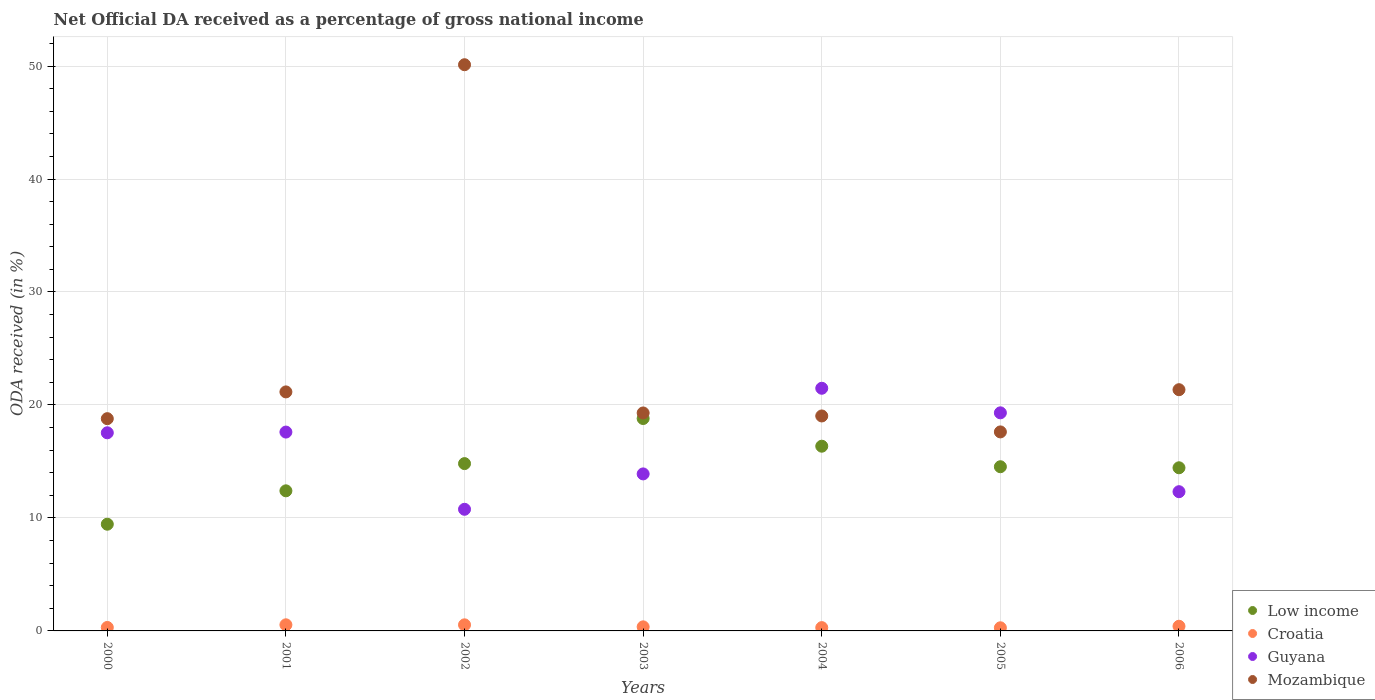How many different coloured dotlines are there?
Give a very brief answer. 4. What is the net official DA received in Mozambique in 2006?
Offer a terse response. 21.35. Across all years, what is the maximum net official DA received in Croatia?
Your answer should be very brief. 0.54. Across all years, what is the minimum net official DA received in Low income?
Your response must be concise. 9.45. In which year was the net official DA received in Mozambique maximum?
Offer a terse response. 2002. In which year was the net official DA received in Croatia minimum?
Your answer should be compact. 2005. What is the total net official DA received in Mozambique in the graph?
Offer a terse response. 167.34. What is the difference between the net official DA received in Low income in 2005 and that in 2006?
Your response must be concise. 0.09. What is the difference between the net official DA received in Mozambique in 2006 and the net official DA received in Croatia in 2004?
Provide a short and direct response. 21.06. What is the average net official DA received in Guyana per year?
Give a very brief answer. 16.13. In the year 2000, what is the difference between the net official DA received in Low income and net official DA received in Guyana?
Keep it short and to the point. -8.09. In how many years, is the net official DA received in Mozambique greater than 16 %?
Ensure brevity in your answer.  7. What is the ratio of the net official DA received in Low income in 2002 to that in 2005?
Your answer should be compact. 1.02. Is the difference between the net official DA received in Low income in 2000 and 2001 greater than the difference between the net official DA received in Guyana in 2000 and 2001?
Make the answer very short. No. What is the difference between the highest and the second highest net official DA received in Guyana?
Ensure brevity in your answer.  2.17. What is the difference between the highest and the lowest net official DA received in Mozambique?
Provide a short and direct response. 32.5. Is the sum of the net official DA received in Low income in 2004 and 2006 greater than the maximum net official DA received in Croatia across all years?
Give a very brief answer. Yes. Is it the case that in every year, the sum of the net official DA received in Mozambique and net official DA received in Low income  is greater than the sum of net official DA received in Guyana and net official DA received in Croatia?
Your answer should be very brief. No. Is it the case that in every year, the sum of the net official DA received in Mozambique and net official DA received in Guyana  is greater than the net official DA received in Croatia?
Your response must be concise. Yes. How many dotlines are there?
Your answer should be compact. 4. Are the values on the major ticks of Y-axis written in scientific E-notation?
Your answer should be compact. No. Does the graph contain grids?
Your answer should be compact. Yes. How are the legend labels stacked?
Ensure brevity in your answer.  Vertical. What is the title of the graph?
Keep it short and to the point. Net Official DA received as a percentage of gross national income. Does "Tuvalu" appear as one of the legend labels in the graph?
Your answer should be compact. No. What is the label or title of the Y-axis?
Ensure brevity in your answer.  ODA received (in %). What is the ODA received (in %) in Low income in 2000?
Your answer should be compact. 9.45. What is the ODA received (in %) of Croatia in 2000?
Offer a very short reply. 0.31. What is the ODA received (in %) in Guyana in 2000?
Your answer should be very brief. 17.54. What is the ODA received (in %) in Mozambique in 2000?
Make the answer very short. 18.79. What is the ODA received (in %) of Low income in 2001?
Your response must be concise. 12.4. What is the ODA received (in %) in Croatia in 2001?
Provide a succinct answer. 0.54. What is the ODA received (in %) of Guyana in 2001?
Keep it short and to the point. 17.6. What is the ODA received (in %) in Mozambique in 2001?
Provide a short and direct response. 21.16. What is the ODA received (in %) in Low income in 2002?
Your response must be concise. 14.81. What is the ODA received (in %) in Croatia in 2002?
Offer a terse response. 0.54. What is the ODA received (in %) in Guyana in 2002?
Ensure brevity in your answer.  10.77. What is the ODA received (in %) in Mozambique in 2002?
Provide a short and direct response. 50.12. What is the ODA received (in %) in Low income in 2003?
Ensure brevity in your answer.  18.8. What is the ODA received (in %) in Croatia in 2003?
Keep it short and to the point. 0.36. What is the ODA received (in %) in Guyana in 2003?
Your response must be concise. 13.9. What is the ODA received (in %) of Mozambique in 2003?
Give a very brief answer. 19.29. What is the ODA received (in %) of Low income in 2004?
Offer a terse response. 16.35. What is the ODA received (in %) in Croatia in 2004?
Offer a terse response. 0.29. What is the ODA received (in %) in Guyana in 2004?
Make the answer very short. 21.48. What is the ODA received (in %) of Mozambique in 2004?
Provide a short and direct response. 19.03. What is the ODA received (in %) in Low income in 2005?
Give a very brief answer. 14.53. What is the ODA received (in %) in Croatia in 2005?
Your answer should be compact. 0.28. What is the ODA received (in %) of Guyana in 2005?
Offer a terse response. 19.3. What is the ODA received (in %) in Mozambique in 2005?
Give a very brief answer. 17.61. What is the ODA received (in %) of Low income in 2006?
Make the answer very short. 14.44. What is the ODA received (in %) of Croatia in 2006?
Ensure brevity in your answer.  0.41. What is the ODA received (in %) of Guyana in 2006?
Your response must be concise. 12.32. What is the ODA received (in %) of Mozambique in 2006?
Ensure brevity in your answer.  21.35. Across all years, what is the maximum ODA received (in %) of Low income?
Your answer should be compact. 18.8. Across all years, what is the maximum ODA received (in %) in Croatia?
Offer a very short reply. 0.54. Across all years, what is the maximum ODA received (in %) in Guyana?
Provide a succinct answer. 21.48. Across all years, what is the maximum ODA received (in %) in Mozambique?
Your answer should be compact. 50.12. Across all years, what is the minimum ODA received (in %) in Low income?
Your answer should be very brief. 9.45. Across all years, what is the minimum ODA received (in %) of Croatia?
Offer a very short reply. 0.28. Across all years, what is the minimum ODA received (in %) of Guyana?
Your answer should be very brief. 10.77. Across all years, what is the minimum ODA received (in %) in Mozambique?
Offer a terse response. 17.61. What is the total ODA received (in %) in Low income in the graph?
Give a very brief answer. 100.78. What is the total ODA received (in %) in Croatia in the graph?
Give a very brief answer. 2.73. What is the total ODA received (in %) of Guyana in the graph?
Provide a succinct answer. 112.91. What is the total ODA received (in %) in Mozambique in the graph?
Your answer should be very brief. 167.34. What is the difference between the ODA received (in %) of Low income in 2000 and that in 2001?
Your response must be concise. -2.95. What is the difference between the ODA received (in %) of Croatia in 2000 and that in 2001?
Keep it short and to the point. -0.23. What is the difference between the ODA received (in %) in Guyana in 2000 and that in 2001?
Keep it short and to the point. -0.06. What is the difference between the ODA received (in %) of Mozambique in 2000 and that in 2001?
Your answer should be very brief. -2.37. What is the difference between the ODA received (in %) in Low income in 2000 and that in 2002?
Offer a very short reply. -5.36. What is the difference between the ODA received (in %) in Croatia in 2000 and that in 2002?
Offer a very short reply. -0.23. What is the difference between the ODA received (in %) in Guyana in 2000 and that in 2002?
Provide a short and direct response. 6.77. What is the difference between the ODA received (in %) in Mozambique in 2000 and that in 2002?
Ensure brevity in your answer.  -31.33. What is the difference between the ODA received (in %) in Low income in 2000 and that in 2003?
Your answer should be very brief. -9.35. What is the difference between the ODA received (in %) in Croatia in 2000 and that in 2003?
Offer a terse response. -0.05. What is the difference between the ODA received (in %) of Guyana in 2000 and that in 2003?
Make the answer very short. 3.64. What is the difference between the ODA received (in %) of Mozambique in 2000 and that in 2003?
Make the answer very short. -0.51. What is the difference between the ODA received (in %) in Low income in 2000 and that in 2004?
Make the answer very short. -6.9. What is the difference between the ODA received (in %) of Croatia in 2000 and that in 2004?
Offer a terse response. 0.01. What is the difference between the ODA received (in %) of Guyana in 2000 and that in 2004?
Your answer should be compact. -3.94. What is the difference between the ODA received (in %) of Mozambique in 2000 and that in 2004?
Your answer should be compact. -0.24. What is the difference between the ODA received (in %) in Low income in 2000 and that in 2005?
Your response must be concise. -5.09. What is the difference between the ODA received (in %) of Croatia in 2000 and that in 2005?
Make the answer very short. 0.03. What is the difference between the ODA received (in %) in Guyana in 2000 and that in 2005?
Provide a succinct answer. -1.77. What is the difference between the ODA received (in %) in Mozambique in 2000 and that in 2005?
Offer a very short reply. 1.17. What is the difference between the ODA received (in %) of Low income in 2000 and that in 2006?
Your response must be concise. -4.99. What is the difference between the ODA received (in %) of Croatia in 2000 and that in 2006?
Make the answer very short. -0.11. What is the difference between the ODA received (in %) in Guyana in 2000 and that in 2006?
Make the answer very short. 5.21. What is the difference between the ODA received (in %) of Mozambique in 2000 and that in 2006?
Your response must be concise. -2.56. What is the difference between the ODA received (in %) in Low income in 2001 and that in 2002?
Make the answer very short. -2.41. What is the difference between the ODA received (in %) of Croatia in 2001 and that in 2002?
Give a very brief answer. 0. What is the difference between the ODA received (in %) of Guyana in 2001 and that in 2002?
Your answer should be compact. 6.83. What is the difference between the ODA received (in %) in Mozambique in 2001 and that in 2002?
Your answer should be very brief. -28.96. What is the difference between the ODA received (in %) of Low income in 2001 and that in 2003?
Provide a succinct answer. -6.4. What is the difference between the ODA received (in %) in Croatia in 2001 and that in 2003?
Ensure brevity in your answer.  0.18. What is the difference between the ODA received (in %) of Guyana in 2001 and that in 2003?
Give a very brief answer. 3.7. What is the difference between the ODA received (in %) of Mozambique in 2001 and that in 2003?
Make the answer very short. 1.86. What is the difference between the ODA received (in %) in Low income in 2001 and that in 2004?
Provide a short and direct response. -3.95. What is the difference between the ODA received (in %) of Croatia in 2001 and that in 2004?
Offer a terse response. 0.25. What is the difference between the ODA received (in %) of Guyana in 2001 and that in 2004?
Your answer should be very brief. -3.88. What is the difference between the ODA received (in %) in Mozambique in 2001 and that in 2004?
Offer a very short reply. 2.13. What is the difference between the ODA received (in %) of Low income in 2001 and that in 2005?
Offer a very short reply. -2.13. What is the difference between the ODA received (in %) in Croatia in 2001 and that in 2005?
Your answer should be very brief. 0.26. What is the difference between the ODA received (in %) in Guyana in 2001 and that in 2005?
Give a very brief answer. -1.7. What is the difference between the ODA received (in %) in Mozambique in 2001 and that in 2005?
Your answer should be compact. 3.54. What is the difference between the ODA received (in %) of Low income in 2001 and that in 2006?
Keep it short and to the point. -2.04. What is the difference between the ODA received (in %) in Croatia in 2001 and that in 2006?
Your answer should be very brief. 0.13. What is the difference between the ODA received (in %) of Guyana in 2001 and that in 2006?
Keep it short and to the point. 5.28. What is the difference between the ODA received (in %) in Mozambique in 2001 and that in 2006?
Give a very brief answer. -0.2. What is the difference between the ODA received (in %) of Low income in 2002 and that in 2003?
Provide a succinct answer. -3.99. What is the difference between the ODA received (in %) of Croatia in 2002 and that in 2003?
Make the answer very short. 0.18. What is the difference between the ODA received (in %) in Guyana in 2002 and that in 2003?
Your answer should be compact. -3.13. What is the difference between the ODA received (in %) in Mozambique in 2002 and that in 2003?
Ensure brevity in your answer.  30.82. What is the difference between the ODA received (in %) of Low income in 2002 and that in 2004?
Make the answer very short. -1.54. What is the difference between the ODA received (in %) of Croatia in 2002 and that in 2004?
Provide a short and direct response. 0.25. What is the difference between the ODA received (in %) of Guyana in 2002 and that in 2004?
Your answer should be very brief. -10.71. What is the difference between the ODA received (in %) in Mozambique in 2002 and that in 2004?
Your response must be concise. 31.09. What is the difference between the ODA received (in %) in Low income in 2002 and that in 2005?
Ensure brevity in your answer.  0.28. What is the difference between the ODA received (in %) of Croatia in 2002 and that in 2005?
Your answer should be compact. 0.26. What is the difference between the ODA received (in %) of Guyana in 2002 and that in 2005?
Your answer should be compact. -8.54. What is the difference between the ODA received (in %) in Mozambique in 2002 and that in 2005?
Make the answer very short. 32.5. What is the difference between the ODA received (in %) of Low income in 2002 and that in 2006?
Your answer should be very brief. 0.37. What is the difference between the ODA received (in %) in Croatia in 2002 and that in 2006?
Give a very brief answer. 0.13. What is the difference between the ODA received (in %) in Guyana in 2002 and that in 2006?
Provide a succinct answer. -1.56. What is the difference between the ODA received (in %) of Mozambique in 2002 and that in 2006?
Ensure brevity in your answer.  28.76. What is the difference between the ODA received (in %) in Low income in 2003 and that in 2004?
Offer a terse response. 2.45. What is the difference between the ODA received (in %) in Croatia in 2003 and that in 2004?
Keep it short and to the point. 0.07. What is the difference between the ODA received (in %) of Guyana in 2003 and that in 2004?
Provide a short and direct response. -7.58. What is the difference between the ODA received (in %) of Mozambique in 2003 and that in 2004?
Make the answer very short. 0.27. What is the difference between the ODA received (in %) of Low income in 2003 and that in 2005?
Offer a very short reply. 4.27. What is the difference between the ODA received (in %) of Croatia in 2003 and that in 2005?
Provide a short and direct response. 0.08. What is the difference between the ODA received (in %) in Guyana in 2003 and that in 2005?
Your answer should be very brief. -5.41. What is the difference between the ODA received (in %) in Mozambique in 2003 and that in 2005?
Your answer should be very brief. 1.68. What is the difference between the ODA received (in %) of Low income in 2003 and that in 2006?
Provide a succinct answer. 4.36. What is the difference between the ODA received (in %) in Croatia in 2003 and that in 2006?
Ensure brevity in your answer.  -0.05. What is the difference between the ODA received (in %) of Guyana in 2003 and that in 2006?
Keep it short and to the point. 1.57. What is the difference between the ODA received (in %) in Mozambique in 2003 and that in 2006?
Keep it short and to the point. -2.06. What is the difference between the ODA received (in %) in Low income in 2004 and that in 2005?
Your response must be concise. 1.82. What is the difference between the ODA received (in %) of Croatia in 2004 and that in 2005?
Offer a terse response. 0.01. What is the difference between the ODA received (in %) of Guyana in 2004 and that in 2005?
Provide a short and direct response. 2.17. What is the difference between the ODA received (in %) in Mozambique in 2004 and that in 2005?
Provide a succinct answer. 1.41. What is the difference between the ODA received (in %) of Low income in 2004 and that in 2006?
Your answer should be very brief. 1.91. What is the difference between the ODA received (in %) of Croatia in 2004 and that in 2006?
Make the answer very short. -0.12. What is the difference between the ODA received (in %) of Guyana in 2004 and that in 2006?
Make the answer very short. 9.15. What is the difference between the ODA received (in %) of Mozambique in 2004 and that in 2006?
Your answer should be compact. -2.33. What is the difference between the ODA received (in %) in Low income in 2005 and that in 2006?
Offer a very short reply. 0.09. What is the difference between the ODA received (in %) of Croatia in 2005 and that in 2006?
Your answer should be compact. -0.14. What is the difference between the ODA received (in %) of Guyana in 2005 and that in 2006?
Offer a terse response. 6.98. What is the difference between the ODA received (in %) in Mozambique in 2005 and that in 2006?
Give a very brief answer. -3.74. What is the difference between the ODA received (in %) of Low income in 2000 and the ODA received (in %) of Croatia in 2001?
Your answer should be compact. 8.9. What is the difference between the ODA received (in %) of Low income in 2000 and the ODA received (in %) of Guyana in 2001?
Give a very brief answer. -8.16. What is the difference between the ODA received (in %) in Low income in 2000 and the ODA received (in %) in Mozambique in 2001?
Provide a short and direct response. -11.71. What is the difference between the ODA received (in %) of Croatia in 2000 and the ODA received (in %) of Guyana in 2001?
Make the answer very short. -17.29. What is the difference between the ODA received (in %) in Croatia in 2000 and the ODA received (in %) in Mozambique in 2001?
Make the answer very short. -20.85. What is the difference between the ODA received (in %) in Guyana in 2000 and the ODA received (in %) in Mozambique in 2001?
Make the answer very short. -3.62. What is the difference between the ODA received (in %) in Low income in 2000 and the ODA received (in %) in Croatia in 2002?
Provide a succinct answer. 8.91. What is the difference between the ODA received (in %) in Low income in 2000 and the ODA received (in %) in Guyana in 2002?
Your answer should be very brief. -1.32. What is the difference between the ODA received (in %) of Low income in 2000 and the ODA received (in %) of Mozambique in 2002?
Provide a succinct answer. -40.67. What is the difference between the ODA received (in %) of Croatia in 2000 and the ODA received (in %) of Guyana in 2002?
Make the answer very short. -10.46. What is the difference between the ODA received (in %) in Croatia in 2000 and the ODA received (in %) in Mozambique in 2002?
Keep it short and to the point. -49.81. What is the difference between the ODA received (in %) in Guyana in 2000 and the ODA received (in %) in Mozambique in 2002?
Provide a succinct answer. -32.58. What is the difference between the ODA received (in %) in Low income in 2000 and the ODA received (in %) in Croatia in 2003?
Provide a succinct answer. 9.09. What is the difference between the ODA received (in %) in Low income in 2000 and the ODA received (in %) in Guyana in 2003?
Your answer should be very brief. -4.45. What is the difference between the ODA received (in %) of Low income in 2000 and the ODA received (in %) of Mozambique in 2003?
Ensure brevity in your answer.  -9.85. What is the difference between the ODA received (in %) of Croatia in 2000 and the ODA received (in %) of Guyana in 2003?
Your response must be concise. -13.59. What is the difference between the ODA received (in %) of Croatia in 2000 and the ODA received (in %) of Mozambique in 2003?
Make the answer very short. -18.99. What is the difference between the ODA received (in %) in Guyana in 2000 and the ODA received (in %) in Mozambique in 2003?
Ensure brevity in your answer.  -1.76. What is the difference between the ODA received (in %) of Low income in 2000 and the ODA received (in %) of Croatia in 2004?
Your answer should be compact. 9.15. What is the difference between the ODA received (in %) of Low income in 2000 and the ODA received (in %) of Guyana in 2004?
Keep it short and to the point. -12.03. What is the difference between the ODA received (in %) in Low income in 2000 and the ODA received (in %) in Mozambique in 2004?
Make the answer very short. -9.58. What is the difference between the ODA received (in %) in Croatia in 2000 and the ODA received (in %) in Guyana in 2004?
Keep it short and to the point. -21.17. What is the difference between the ODA received (in %) of Croatia in 2000 and the ODA received (in %) of Mozambique in 2004?
Make the answer very short. -18.72. What is the difference between the ODA received (in %) in Guyana in 2000 and the ODA received (in %) in Mozambique in 2004?
Provide a short and direct response. -1.49. What is the difference between the ODA received (in %) of Low income in 2000 and the ODA received (in %) of Croatia in 2005?
Keep it short and to the point. 9.17. What is the difference between the ODA received (in %) of Low income in 2000 and the ODA received (in %) of Guyana in 2005?
Offer a terse response. -9.86. What is the difference between the ODA received (in %) of Low income in 2000 and the ODA received (in %) of Mozambique in 2005?
Your response must be concise. -8.17. What is the difference between the ODA received (in %) in Croatia in 2000 and the ODA received (in %) in Guyana in 2005?
Make the answer very short. -19. What is the difference between the ODA received (in %) of Croatia in 2000 and the ODA received (in %) of Mozambique in 2005?
Give a very brief answer. -17.31. What is the difference between the ODA received (in %) in Guyana in 2000 and the ODA received (in %) in Mozambique in 2005?
Keep it short and to the point. -0.08. What is the difference between the ODA received (in %) of Low income in 2000 and the ODA received (in %) of Croatia in 2006?
Ensure brevity in your answer.  9.03. What is the difference between the ODA received (in %) of Low income in 2000 and the ODA received (in %) of Guyana in 2006?
Your answer should be very brief. -2.88. What is the difference between the ODA received (in %) in Low income in 2000 and the ODA received (in %) in Mozambique in 2006?
Ensure brevity in your answer.  -11.91. What is the difference between the ODA received (in %) in Croatia in 2000 and the ODA received (in %) in Guyana in 2006?
Give a very brief answer. -12.02. What is the difference between the ODA received (in %) in Croatia in 2000 and the ODA received (in %) in Mozambique in 2006?
Provide a short and direct response. -21.05. What is the difference between the ODA received (in %) of Guyana in 2000 and the ODA received (in %) of Mozambique in 2006?
Ensure brevity in your answer.  -3.81. What is the difference between the ODA received (in %) of Low income in 2001 and the ODA received (in %) of Croatia in 2002?
Offer a very short reply. 11.86. What is the difference between the ODA received (in %) of Low income in 2001 and the ODA received (in %) of Guyana in 2002?
Make the answer very short. 1.63. What is the difference between the ODA received (in %) in Low income in 2001 and the ODA received (in %) in Mozambique in 2002?
Give a very brief answer. -37.72. What is the difference between the ODA received (in %) of Croatia in 2001 and the ODA received (in %) of Guyana in 2002?
Provide a succinct answer. -10.22. What is the difference between the ODA received (in %) in Croatia in 2001 and the ODA received (in %) in Mozambique in 2002?
Make the answer very short. -49.57. What is the difference between the ODA received (in %) in Guyana in 2001 and the ODA received (in %) in Mozambique in 2002?
Offer a terse response. -32.51. What is the difference between the ODA received (in %) in Low income in 2001 and the ODA received (in %) in Croatia in 2003?
Your response must be concise. 12.04. What is the difference between the ODA received (in %) of Low income in 2001 and the ODA received (in %) of Guyana in 2003?
Your answer should be very brief. -1.5. What is the difference between the ODA received (in %) of Low income in 2001 and the ODA received (in %) of Mozambique in 2003?
Keep it short and to the point. -6.89. What is the difference between the ODA received (in %) in Croatia in 2001 and the ODA received (in %) in Guyana in 2003?
Offer a very short reply. -13.36. What is the difference between the ODA received (in %) of Croatia in 2001 and the ODA received (in %) of Mozambique in 2003?
Provide a succinct answer. -18.75. What is the difference between the ODA received (in %) in Guyana in 2001 and the ODA received (in %) in Mozambique in 2003?
Keep it short and to the point. -1.69. What is the difference between the ODA received (in %) in Low income in 2001 and the ODA received (in %) in Croatia in 2004?
Make the answer very short. 12.11. What is the difference between the ODA received (in %) in Low income in 2001 and the ODA received (in %) in Guyana in 2004?
Your answer should be compact. -9.08. What is the difference between the ODA received (in %) in Low income in 2001 and the ODA received (in %) in Mozambique in 2004?
Give a very brief answer. -6.63. What is the difference between the ODA received (in %) of Croatia in 2001 and the ODA received (in %) of Guyana in 2004?
Provide a short and direct response. -20.94. What is the difference between the ODA received (in %) in Croatia in 2001 and the ODA received (in %) in Mozambique in 2004?
Your response must be concise. -18.48. What is the difference between the ODA received (in %) in Guyana in 2001 and the ODA received (in %) in Mozambique in 2004?
Offer a very short reply. -1.43. What is the difference between the ODA received (in %) of Low income in 2001 and the ODA received (in %) of Croatia in 2005?
Your response must be concise. 12.12. What is the difference between the ODA received (in %) in Low income in 2001 and the ODA received (in %) in Guyana in 2005?
Offer a terse response. -6.9. What is the difference between the ODA received (in %) of Low income in 2001 and the ODA received (in %) of Mozambique in 2005?
Offer a terse response. -5.21. What is the difference between the ODA received (in %) of Croatia in 2001 and the ODA received (in %) of Guyana in 2005?
Make the answer very short. -18.76. What is the difference between the ODA received (in %) in Croatia in 2001 and the ODA received (in %) in Mozambique in 2005?
Your response must be concise. -17.07. What is the difference between the ODA received (in %) in Guyana in 2001 and the ODA received (in %) in Mozambique in 2005?
Keep it short and to the point. -0.01. What is the difference between the ODA received (in %) in Low income in 2001 and the ODA received (in %) in Croatia in 2006?
Offer a very short reply. 11.99. What is the difference between the ODA received (in %) in Low income in 2001 and the ODA received (in %) in Guyana in 2006?
Provide a short and direct response. 0.08. What is the difference between the ODA received (in %) in Low income in 2001 and the ODA received (in %) in Mozambique in 2006?
Provide a succinct answer. -8.95. What is the difference between the ODA received (in %) of Croatia in 2001 and the ODA received (in %) of Guyana in 2006?
Provide a short and direct response. -11.78. What is the difference between the ODA received (in %) of Croatia in 2001 and the ODA received (in %) of Mozambique in 2006?
Make the answer very short. -20.81. What is the difference between the ODA received (in %) of Guyana in 2001 and the ODA received (in %) of Mozambique in 2006?
Offer a terse response. -3.75. What is the difference between the ODA received (in %) of Low income in 2002 and the ODA received (in %) of Croatia in 2003?
Your response must be concise. 14.45. What is the difference between the ODA received (in %) of Low income in 2002 and the ODA received (in %) of Guyana in 2003?
Your answer should be very brief. 0.91. What is the difference between the ODA received (in %) in Low income in 2002 and the ODA received (in %) in Mozambique in 2003?
Make the answer very short. -4.48. What is the difference between the ODA received (in %) in Croatia in 2002 and the ODA received (in %) in Guyana in 2003?
Give a very brief answer. -13.36. What is the difference between the ODA received (in %) of Croatia in 2002 and the ODA received (in %) of Mozambique in 2003?
Provide a succinct answer. -18.75. What is the difference between the ODA received (in %) of Guyana in 2002 and the ODA received (in %) of Mozambique in 2003?
Offer a very short reply. -8.53. What is the difference between the ODA received (in %) of Low income in 2002 and the ODA received (in %) of Croatia in 2004?
Ensure brevity in your answer.  14.52. What is the difference between the ODA received (in %) in Low income in 2002 and the ODA received (in %) in Guyana in 2004?
Your response must be concise. -6.67. What is the difference between the ODA received (in %) in Low income in 2002 and the ODA received (in %) in Mozambique in 2004?
Make the answer very short. -4.22. What is the difference between the ODA received (in %) in Croatia in 2002 and the ODA received (in %) in Guyana in 2004?
Your answer should be compact. -20.94. What is the difference between the ODA received (in %) of Croatia in 2002 and the ODA received (in %) of Mozambique in 2004?
Ensure brevity in your answer.  -18.49. What is the difference between the ODA received (in %) of Guyana in 2002 and the ODA received (in %) of Mozambique in 2004?
Make the answer very short. -8.26. What is the difference between the ODA received (in %) of Low income in 2002 and the ODA received (in %) of Croatia in 2005?
Provide a succinct answer. 14.53. What is the difference between the ODA received (in %) of Low income in 2002 and the ODA received (in %) of Guyana in 2005?
Offer a very short reply. -4.49. What is the difference between the ODA received (in %) of Low income in 2002 and the ODA received (in %) of Mozambique in 2005?
Keep it short and to the point. -2.81. What is the difference between the ODA received (in %) in Croatia in 2002 and the ODA received (in %) in Guyana in 2005?
Provide a short and direct response. -18.76. What is the difference between the ODA received (in %) in Croatia in 2002 and the ODA received (in %) in Mozambique in 2005?
Your response must be concise. -17.08. What is the difference between the ODA received (in %) of Guyana in 2002 and the ODA received (in %) of Mozambique in 2005?
Give a very brief answer. -6.85. What is the difference between the ODA received (in %) in Low income in 2002 and the ODA received (in %) in Croatia in 2006?
Your response must be concise. 14.4. What is the difference between the ODA received (in %) of Low income in 2002 and the ODA received (in %) of Guyana in 2006?
Provide a succinct answer. 2.49. What is the difference between the ODA received (in %) in Low income in 2002 and the ODA received (in %) in Mozambique in 2006?
Your answer should be very brief. -6.54. What is the difference between the ODA received (in %) in Croatia in 2002 and the ODA received (in %) in Guyana in 2006?
Your answer should be very brief. -11.78. What is the difference between the ODA received (in %) of Croatia in 2002 and the ODA received (in %) of Mozambique in 2006?
Keep it short and to the point. -20.81. What is the difference between the ODA received (in %) in Guyana in 2002 and the ODA received (in %) in Mozambique in 2006?
Make the answer very short. -10.59. What is the difference between the ODA received (in %) in Low income in 2003 and the ODA received (in %) in Croatia in 2004?
Offer a terse response. 18.51. What is the difference between the ODA received (in %) of Low income in 2003 and the ODA received (in %) of Guyana in 2004?
Keep it short and to the point. -2.68. What is the difference between the ODA received (in %) of Low income in 2003 and the ODA received (in %) of Mozambique in 2004?
Offer a very short reply. -0.23. What is the difference between the ODA received (in %) in Croatia in 2003 and the ODA received (in %) in Guyana in 2004?
Make the answer very short. -21.12. What is the difference between the ODA received (in %) of Croatia in 2003 and the ODA received (in %) of Mozambique in 2004?
Your answer should be very brief. -18.67. What is the difference between the ODA received (in %) of Guyana in 2003 and the ODA received (in %) of Mozambique in 2004?
Your answer should be compact. -5.13. What is the difference between the ODA received (in %) in Low income in 2003 and the ODA received (in %) in Croatia in 2005?
Your answer should be compact. 18.52. What is the difference between the ODA received (in %) of Low income in 2003 and the ODA received (in %) of Guyana in 2005?
Your response must be concise. -0.5. What is the difference between the ODA received (in %) in Low income in 2003 and the ODA received (in %) in Mozambique in 2005?
Keep it short and to the point. 1.19. What is the difference between the ODA received (in %) in Croatia in 2003 and the ODA received (in %) in Guyana in 2005?
Make the answer very short. -18.94. What is the difference between the ODA received (in %) in Croatia in 2003 and the ODA received (in %) in Mozambique in 2005?
Offer a terse response. -17.25. What is the difference between the ODA received (in %) of Guyana in 2003 and the ODA received (in %) of Mozambique in 2005?
Your answer should be compact. -3.72. What is the difference between the ODA received (in %) in Low income in 2003 and the ODA received (in %) in Croatia in 2006?
Keep it short and to the point. 18.39. What is the difference between the ODA received (in %) of Low income in 2003 and the ODA received (in %) of Guyana in 2006?
Your answer should be very brief. 6.48. What is the difference between the ODA received (in %) of Low income in 2003 and the ODA received (in %) of Mozambique in 2006?
Your answer should be compact. -2.55. What is the difference between the ODA received (in %) in Croatia in 2003 and the ODA received (in %) in Guyana in 2006?
Your answer should be very brief. -11.96. What is the difference between the ODA received (in %) of Croatia in 2003 and the ODA received (in %) of Mozambique in 2006?
Your response must be concise. -20.99. What is the difference between the ODA received (in %) in Guyana in 2003 and the ODA received (in %) in Mozambique in 2006?
Provide a succinct answer. -7.45. What is the difference between the ODA received (in %) of Low income in 2004 and the ODA received (in %) of Croatia in 2005?
Offer a very short reply. 16.07. What is the difference between the ODA received (in %) in Low income in 2004 and the ODA received (in %) in Guyana in 2005?
Ensure brevity in your answer.  -2.95. What is the difference between the ODA received (in %) of Low income in 2004 and the ODA received (in %) of Mozambique in 2005?
Ensure brevity in your answer.  -1.26. What is the difference between the ODA received (in %) in Croatia in 2004 and the ODA received (in %) in Guyana in 2005?
Give a very brief answer. -19.01. What is the difference between the ODA received (in %) of Croatia in 2004 and the ODA received (in %) of Mozambique in 2005?
Your response must be concise. -17.32. What is the difference between the ODA received (in %) in Guyana in 2004 and the ODA received (in %) in Mozambique in 2005?
Make the answer very short. 3.86. What is the difference between the ODA received (in %) of Low income in 2004 and the ODA received (in %) of Croatia in 2006?
Your response must be concise. 15.94. What is the difference between the ODA received (in %) in Low income in 2004 and the ODA received (in %) in Guyana in 2006?
Provide a succinct answer. 4.03. What is the difference between the ODA received (in %) in Low income in 2004 and the ODA received (in %) in Mozambique in 2006?
Keep it short and to the point. -5. What is the difference between the ODA received (in %) in Croatia in 2004 and the ODA received (in %) in Guyana in 2006?
Provide a succinct answer. -12.03. What is the difference between the ODA received (in %) of Croatia in 2004 and the ODA received (in %) of Mozambique in 2006?
Keep it short and to the point. -21.06. What is the difference between the ODA received (in %) of Guyana in 2004 and the ODA received (in %) of Mozambique in 2006?
Offer a terse response. 0.13. What is the difference between the ODA received (in %) in Low income in 2005 and the ODA received (in %) in Croatia in 2006?
Provide a succinct answer. 14.12. What is the difference between the ODA received (in %) in Low income in 2005 and the ODA received (in %) in Guyana in 2006?
Your answer should be very brief. 2.21. What is the difference between the ODA received (in %) of Low income in 2005 and the ODA received (in %) of Mozambique in 2006?
Make the answer very short. -6.82. What is the difference between the ODA received (in %) of Croatia in 2005 and the ODA received (in %) of Guyana in 2006?
Make the answer very short. -12.05. What is the difference between the ODA received (in %) in Croatia in 2005 and the ODA received (in %) in Mozambique in 2006?
Ensure brevity in your answer.  -21.07. What is the difference between the ODA received (in %) of Guyana in 2005 and the ODA received (in %) of Mozambique in 2006?
Give a very brief answer. -2.05. What is the average ODA received (in %) in Low income per year?
Your answer should be very brief. 14.4. What is the average ODA received (in %) in Croatia per year?
Your answer should be very brief. 0.39. What is the average ODA received (in %) of Guyana per year?
Keep it short and to the point. 16.13. What is the average ODA received (in %) in Mozambique per year?
Give a very brief answer. 23.91. In the year 2000, what is the difference between the ODA received (in %) of Low income and ODA received (in %) of Croatia?
Offer a very short reply. 9.14. In the year 2000, what is the difference between the ODA received (in %) in Low income and ODA received (in %) in Guyana?
Ensure brevity in your answer.  -8.09. In the year 2000, what is the difference between the ODA received (in %) in Low income and ODA received (in %) in Mozambique?
Give a very brief answer. -9.34. In the year 2000, what is the difference between the ODA received (in %) in Croatia and ODA received (in %) in Guyana?
Ensure brevity in your answer.  -17.23. In the year 2000, what is the difference between the ODA received (in %) in Croatia and ODA received (in %) in Mozambique?
Your response must be concise. -18.48. In the year 2000, what is the difference between the ODA received (in %) of Guyana and ODA received (in %) of Mozambique?
Offer a very short reply. -1.25. In the year 2001, what is the difference between the ODA received (in %) in Low income and ODA received (in %) in Croatia?
Your response must be concise. 11.86. In the year 2001, what is the difference between the ODA received (in %) of Low income and ODA received (in %) of Guyana?
Your answer should be very brief. -5.2. In the year 2001, what is the difference between the ODA received (in %) in Low income and ODA received (in %) in Mozambique?
Give a very brief answer. -8.76. In the year 2001, what is the difference between the ODA received (in %) in Croatia and ODA received (in %) in Guyana?
Keep it short and to the point. -17.06. In the year 2001, what is the difference between the ODA received (in %) in Croatia and ODA received (in %) in Mozambique?
Give a very brief answer. -20.61. In the year 2001, what is the difference between the ODA received (in %) of Guyana and ODA received (in %) of Mozambique?
Make the answer very short. -3.56. In the year 2002, what is the difference between the ODA received (in %) in Low income and ODA received (in %) in Croatia?
Offer a terse response. 14.27. In the year 2002, what is the difference between the ODA received (in %) in Low income and ODA received (in %) in Guyana?
Offer a terse response. 4.04. In the year 2002, what is the difference between the ODA received (in %) in Low income and ODA received (in %) in Mozambique?
Make the answer very short. -35.31. In the year 2002, what is the difference between the ODA received (in %) of Croatia and ODA received (in %) of Guyana?
Provide a short and direct response. -10.23. In the year 2002, what is the difference between the ODA received (in %) of Croatia and ODA received (in %) of Mozambique?
Offer a very short reply. -49.58. In the year 2002, what is the difference between the ODA received (in %) in Guyana and ODA received (in %) in Mozambique?
Provide a short and direct response. -39.35. In the year 2003, what is the difference between the ODA received (in %) of Low income and ODA received (in %) of Croatia?
Your response must be concise. 18.44. In the year 2003, what is the difference between the ODA received (in %) in Low income and ODA received (in %) in Guyana?
Make the answer very short. 4.9. In the year 2003, what is the difference between the ODA received (in %) in Low income and ODA received (in %) in Mozambique?
Ensure brevity in your answer.  -0.49. In the year 2003, what is the difference between the ODA received (in %) of Croatia and ODA received (in %) of Guyana?
Keep it short and to the point. -13.54. In the year 2003, what is the difference between the ODA received (in %) in Croatia and ODA received (in %) in Mozambique?
Offer a terse response. -18.93. In the year 2003, what is the difference between the ODA received (in %) of Guyana and ODA received (in %) of Mozambique?
Your response must be concise. -5.4. In the year 2004, what is the difference between the ODA received (in %) of Low income and ODA received (in %) of Croatia?
Give a very brief answer. 16.06. In the year 2004, what is the difference between the ODA received (in %) in Low income and ODA received (in %) in Guyana?
Provide a succinct answer. -5.13. In the year 2004, what is the difference between the ODA received (in %) in Low income and ODA received (in %) in Mozambique?
Keep it short and to the point. -2.68. In the year 2004, what is the difference between the ODA received (in %) of Croatia and ODA received (in %) of Guyana?
Offer a very short reply. -21.19. In the year 2004, what is the difference between the ODA received (in %) in Croatia and ODA received (in %) in Mozambique?
Provide a short and direct response. -18.73. In the year 2004, what is the difference between the ODA received (in %) of Guyana and ODA received (in %) of Mozambique?
Your answer should be very brief. 2.45. In the year 2005, what is the difference between the ODA received (in %) of Low income and ODA received (in %) of Croatia?
Keep it short and to the point. 14.26. In the year 2005, what is the difference between the ODA received (in %) of Low income and ODA received (in %) of Guyana?
Your response must be concise. -4.77. In the year 2005, what is the difference between the ODA received (in %) of Low income and ODA received (in %) of Mozambique?
Offer a terse response. -3.08. In the year 2005, what is the difference between the ODA received (in %) in Croatia and ODA received (in %) in Guyana?
Ensure brevity in your answer.  -19.03. In the year 2005, what is the difference between the ODA received (in %) of Croatia and ODA received (in %) of Mozambique?
Keep it short and to the point. -17.34. In the year 2005, what is the difference between the ODA received (in %) in Guyana and ODA received (in %) in Mozambique?
Your answer should be compact. 1.69. In the year 2006, what is the difference between the ODA received (in %) of Low income and ODA received (in %) of Croatia?
Give a very brief answer. 14.03. In the year 2006, what is the difference between the ODA received (in %) in Low income and ODA received (in %) in Guyana?
Ensure brevity in your answer.  2.12. In the year 2006, what is the difference between the ODA received (in %) of Low income and ODA received (in %) of Mozambique?
Your answer should be compact. -6.91. In the year 2006, what is the difference between the ODA received (in %) in Croatia and ODA received (in %) in Guyana?
Give a very brief answer. -11.91. In the year 2006, what is the difference between the ODA received (in %) of Croatia and ODA received (in %) of Mozambique?
Ensure brevity in your answer.  -20.94. In the year 2006, what is the difference between the ODA received (in %) in Guyana and ODA received (in %) in Mozambique?
Offer a very short reply. -9.03. What is the ratio of the ODA received (in %) in Low income in 2000 to that in 2001?
Provide a succinct answer. 0.76. What is the ratio of the ODA received (in %) of Croatia in 2000 to that in 2001?
Offer a very short reply. 0.57. What is the ratio of the ODA received (in %) of Mozambique in 2000 to that in 2001?
Your answer should be very brief. 0.89. What is the ratio of the ODA received (in %) of Low income in 2000 to that in 2002?
Provide a short and direct response. 0.64. What is the ratio of the ODA received (in %) of Croatia in 2000 to that in 2002?
Provide a short and direct response. 0.57. What is the ratio of the ODA received (in %) of Guyana in 2000 to that in 2002?
Make the answer very short. 1.63. What is the ratio of the ODA received (in %) in Mozambique in 2000 to that in 2002?
Provide a succinct answer. 0.37. What is the ratio of the ODA received (in %) in Low income in 2000 to that in 2003?
Your answer should be very brief. 0.5. What is the ratio of the ODA received (in %) of Croatia in 2000 to that in 2003?
Make the answer very short. 0.85. What is the ratio of the ODA received (in %) of Guyana in 2000 to that in 2003?
Provide a short and direct response. 1.26. What is the ratio of the ODA received (in %) of Mozambique in 2000 to that in 2003?
Your answer should be compact. 0.97. What is the ratio of the ODA received (in %) in Low income in 2000 to that in 2004?
Your answer should be compact. 0.58. What is the ratio of the ODA received (in %) of Croatia in 2000 to that in 2004?
Your response must be concise. 1.05. What is the ratio of the ODA received (in %) of Guyana in 2000 to that in 2004?
Offer a terse response. 0.82. What is the ratio of the ODA received (in %) in Mozambique in 2000 to that in 2004?
Make the answer very short. 0.99. What is the ratio of the ODA received (in %) in Low income in 2000 to that in 2005?
Your answer should be very brief. 0.65. What is the ratio of the ODA received (in %) in Croatia in 2000 to that in 2005?
Your answer should be compact. 1.1. What is the ratio of the ODA received (in %) in Guyana in 2000 to that in 2005?
Offer a very short reply. 0.91. What is the ratio of the ODA received (in %) in Mozambique in 2000 to that in 2005?
Offer a very short reply. 1.07. What is the ratio of the ODA received (in %) in Low income in 2000 to that in 2006?
Provide a short and direct response. 0.65. What is the ratio of the ODA received (in %) in Croatia in 2000 to that in 2006?
Ensure brevity in your answer.  0.74. What is the ratio of the ODA received (in %) in Guyana in 2000 to that in 2006?
Your answer should be compact. 1.42. What is the ratio of the ODA received (in %) of Mozambique in 2000 to that in 2006?
Make the answer very short. 0.88. What is the ratio of the ODA received (in %) of Low income in 2001 to that in 2002?
Make the answer very short. 0.84. What is the ratio of the ODA received (in %) of Guyana in 2001 to that in 2002?
Keep it short and to the point. 1.63. What is the ratio of the ODA received (in %) in Mozambique in 2001 to that in 2002?
Make the answer very short. 0.42. What is the ratio of the ODA received (in %) in Low income in 2001 to that in 2003?
Give a very brief answer. 0.66. What is the ratio of the ODA received (in %) of Croatia in 2001 to that in 2003?
Offer a very short reply. 1.5. What is the ratio of the ODA received (in %) in Guyana in 2001 to that in 2003?
Provide a short and direct response. 1.27. What is the ratio of the ODA received (in %) of Mozambique in 2001 to that in 2003?
Your response must be concise. 1.1. What is the ratio of the ODA received (in %) in Low income in 2001 to that in 2004?
Provide a short and direct response. 0.76. What is the ratio of the ODA received (in %) in Croatia in 2001 to that in 2004?
Offer a terse response. 1.85. What is the ratio of the ODA received (in %) of Guyana in 2001 to that in 2004?
Offer a very short reply. 0.82. What is the ratio of the ODA received (in %) of Mozambique in 2001 to that in 2004?
Keep it short and to the point. 1.11. What is the ratio of the ODA received (in %) of Low income in 2001 to that in 2005?
Keep it short and to the point. 0.85. What is the ratio of the ODA received (in %) of Croatia in 2001 to that in 2005?
Ensure brevity in your answer.  1.95. What is the ratio of the ODA received (in %) in Guyana in 2001 to that in 2005?
Your response must be concise. 0.91. What is the ratio of the ODA received (in %) of Mozambique in 2001 to that in 2005?
Give a very brief answer. 1.2. What is the ratio of the ODA received (in %) of Low income in 2001 to that in 2006?
Make the answer very short. 0.86. What is the ratio of the ODA received (in %) of Croatia in 2001 to that in 2006?
Provide a succinct answer. 1.31. What is the ratio of the ODA received (in %) in Guyana in 2001 to that in 2006?
Give a very brief answer. 1.43. What is the ratio of the ODA received (in %) in Low income in 2002 to that in 2003?
Your response must be concise. 0.79. What is the ratio of the ODA received (in %) of Croatia in 2002 to that in 2003?
Give a very brief answer. 1.5. What is the ratio of the ODA received (in %) in Guyana in 2002 to that in 2003?
Keep it short and to the point. 0.77. What is the ratio of the ODA received (in %) of Mozambique in 2002 to that in 2003?
Give a very brief answer. 2.6. What is the ratio of the ODA received (in %) of Low income in 2002 to that in 2004?
Provide a short and direct response. 0.91. What is the ratio of the ODA received (in %) in Croatia in 2002 to that in 2004?
Offer a terse response. 1.84. What is the ratio of the ODA received (in %) in Guyana in 2002 to that in 2004?
Provide a succinct answer. 0.5. What is the ratio of the ODA received (in %) in Mozambique in 2002 to that in 2004?
Keep it short and to the point. 2.63. What is the ratio of the ODA received (in %) in Croatia in 2002 to that in 2005?
Your answer should be compact. 1.94. What is the ratio of the ODA received (in %) of Guyana in 2002 to that in 2005?
Your answer should be compact. 0.56. What is the ratio of the ODA received (in %) of Mozambique in 2002 to that in 2005?
Offer a very short reply. 2.85. What is the ratio of the ODA received (in %) of Low income in 2002 to that in 2006?
Ensure brevity in your answer.  1.03. What is the ratio of the ODA received (in %) of Croatia in 2002 to that in 2006?
Ensure brevity in your answer.  1.3. What is the ratio of the ODA received (in %) in Guyana in 2002 to that in 2006?
Offer a terse response. 0.87. What is the ratio of the ODA received (in %) of Mozambique in 2002 to that in 2006?
Offer a terse response. 2.35. What is the ratio of the ODA received (in %) in Low income in 2003 to that in 2004?
Your answer should be very brief. 1.15. What is the ratio of the ODA received (in %) in Croatia in 2003 to that in 2004?
Offer a terse response. 1.23. What is the ratio of the ODA received (in %) of Guyana in 2003 to that in 2004?
Give a very brief answer. 0.65. What is the ratio of the ODA received (in %) of Mozambique in 2003 to that in 2004?
Ensure brevity in your answer.  1.01. What is the ratio of the ODA received (in %) in Low income in 2003 to that in 2005?
Your answer should be compact. 1.29. What is the ratio of the ODA received (in %) of Croatia in 2003 to that in 2005?
Offer a terse response. 1.3. What is the ratio of the ODA received (in %) of Guyana in 2003 to that in 2005?
Provide a short and direct response. 0.72. What is the ratio of the ODA received (in %) in Mozambique in 2003 to that in 2005?
Offer a very short reply. 1.1. What is the ratio of the ODA received (in %) in Low income in 2003 to that in 2006?
Provide a short and direct response. 1.3. What is the ratio of the ODA received (in %) of Croatia in 2003 to that in 2006?
Your response must be concise. 0.87. What is the ratio of the ODA received (in %) in Guyana in 2003 to that in 2006?
Your answer should be very brief. 1.13. What is the ratio of the ODA received (in %) of Mozambique in 2003 to that in 2006?
Make the answer very short. 0.9. What is the ratio of the ODA received (in %) of Low income in 2004 to that in 2005?
Provide a succinct answer. 1.12. What is the ratio of the ODA received (in %) of Croatia in 2004 to that in 2005?
Your response must be concise. 1.05. What is the ratio of the ODA received (in %) in Guyana in 2004 to that in 2005?
Offer a terse response. 1.11. What is the ratio of the ODA received (in %) of Mozambique in 2004 to that in 2005?
Give a very brief answer. 1.08. What is the ratio of the ODA received (in %) in Low income in 2004 to that in 2006?
Provide a short and direct response. 1.13. What is the ratio of the ODA received (in %) of Croatia in 2004 to that in 2006?
Give a very brief answer. 0.71. What is the ratio of the ODA received (in %) of Guyana in 2004 to that in 2006?
Your answer should be compact. 1.74. What is the ratio of the ODA received (in %) in Mozambique in 2004 to that in 2006?
Offer a terse response. 0.89. What is the ratio of the ODA received (in %) in Low income in 2005 to that in 2006?
Your response must be concise. 1.01. What is the ratio of the ODA received (in %) in Croatia in 2005 to that in 2006?
Offer a very short reply. 0.67. What is the ratio of the ODA received (in %) in Guyana in 2005 to that in 2006?
Provide a succinct answer. 1.57. What is the ratio of the ODA received (in %) in Mozambique in 2005 to that in 2006?
Offer a very short reply. 0.82. What is the difference between the highest and the second highest ODA received (in %) of Low income?
Give a very brief answer. 2.45. What is the difference between the highest and the second highest ODA received (in %) in Croatia?
Make the answer very short. 0. What is the difference between the highest and the second highest ODA received (in %) in Guyana?
Make the answer very short. 2.17. What is the difference between the highest and the second highest ODA received (in %) in Mozambique?
Give a very brief answer. 28.76. What is the difference between the highest and the lowest ODA received (in %) in Low income?
Provide a succinct answer. 9.35. What is the difference between the highest and the lowest ODA received (in %) in Croatia?
Ensure brevity in your answer.  0.26. What is the difference between the highest and the lowest ODA received (in %) of Guyana?
Your response must be concise. 10.71. What is the difference between the highest and the lowest ODA received (in %) of Mozambique?
Offer a very short reply. 32.5. 